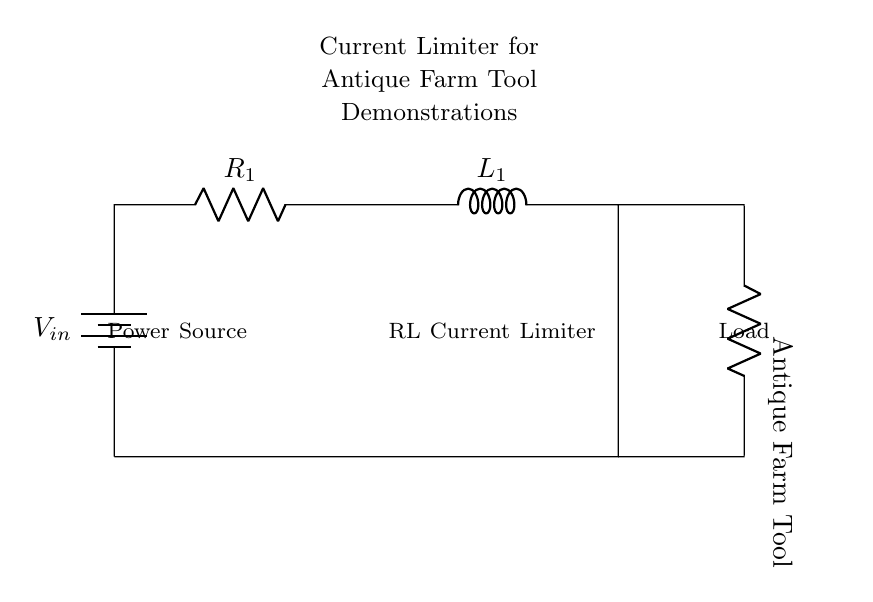What type of components are used in this circuit? The circuit contains a battery, a resistor, an inductor, and an antique farm tool, which are the distinct components represented.
Answer: battery, resistor, inductor, antique farm tool What is the primary function of this circuit? The circuit functions as a current limiter to ensure safe operation of antique farm tools, preventing overload during demonstrations.
Answer: current limiter How many components are used in the circuit? The circuit consists of four components: a battery, a resistor, an inductor, and a load (antique farm tool).
Answer: four What is the label of the load in this circuit? The load in this circuit is labeled as "Antique Farm Tool," indicating that the circuit is designed to power this specific type of equipment safely.
Answer: Antique Farm Tool Why is an inductor included in this circuit? The inductor is included to limit the current and provide stability to the power supplied to the antique farm tools, helping to prevent sudden surges that could damage the equipment.
Answer: to limit current What is the role of the resistor in this circuit? The resistor helps to control the amount of current flowing through the circuit, contributing to the overall current limiting effect of the circuit.
Answer: to control current What could happen if the circuit were designed without a current limiter? Without a current limiter, the antique farm tools could be exposed to excessive current, which could result in overheating or damage to the equipment during usage.
Answer: overheating or damage 